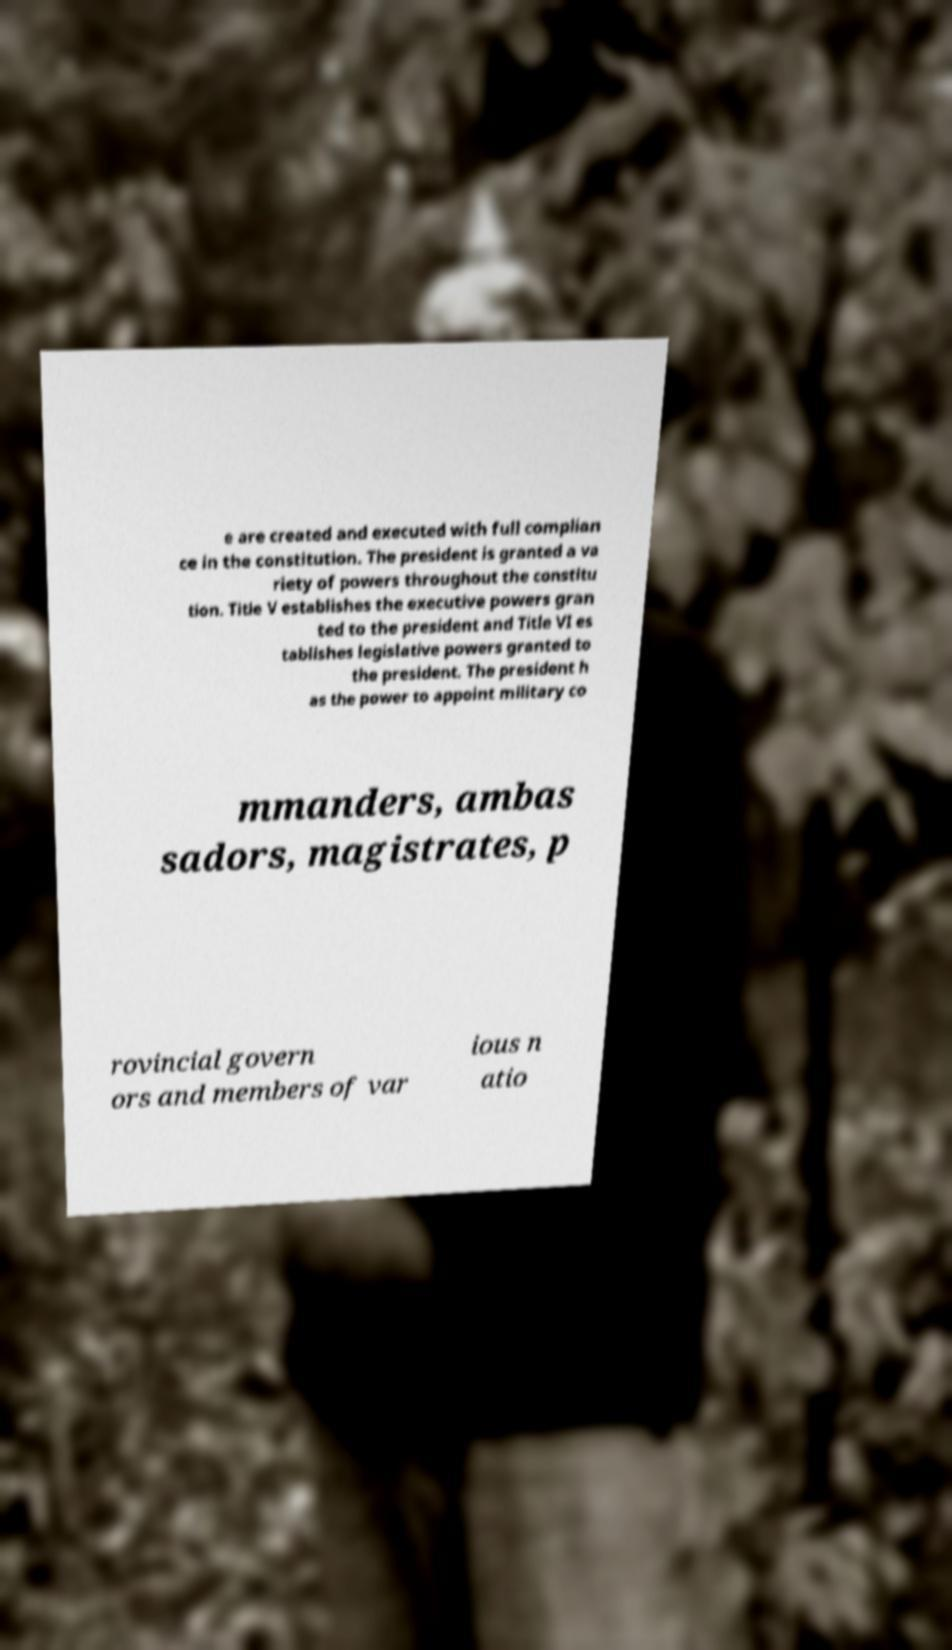Please read and relay the text visible in this image. What does it say? e are created and executed with full complian ce in the constitution. The president is granted a va riety of powers throughout the constitu tion. Title V establishes the executive powers gran ted to the president and Title VI es tablishes legislative powers granted to the president. The president h as the power to appoint military co mmanders, ambas sadors, magistrates, p rovincial govern ors and members of var ious n atio 